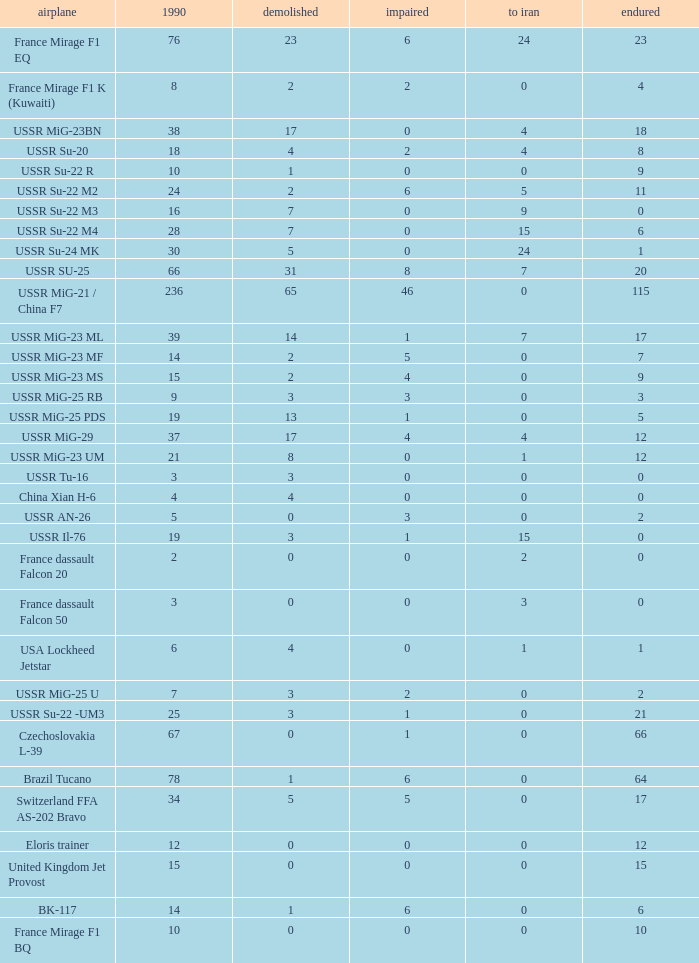Given that 14 existed in 1990 and 6 are still around, what is the number of those that were destroyed? 1.0. 